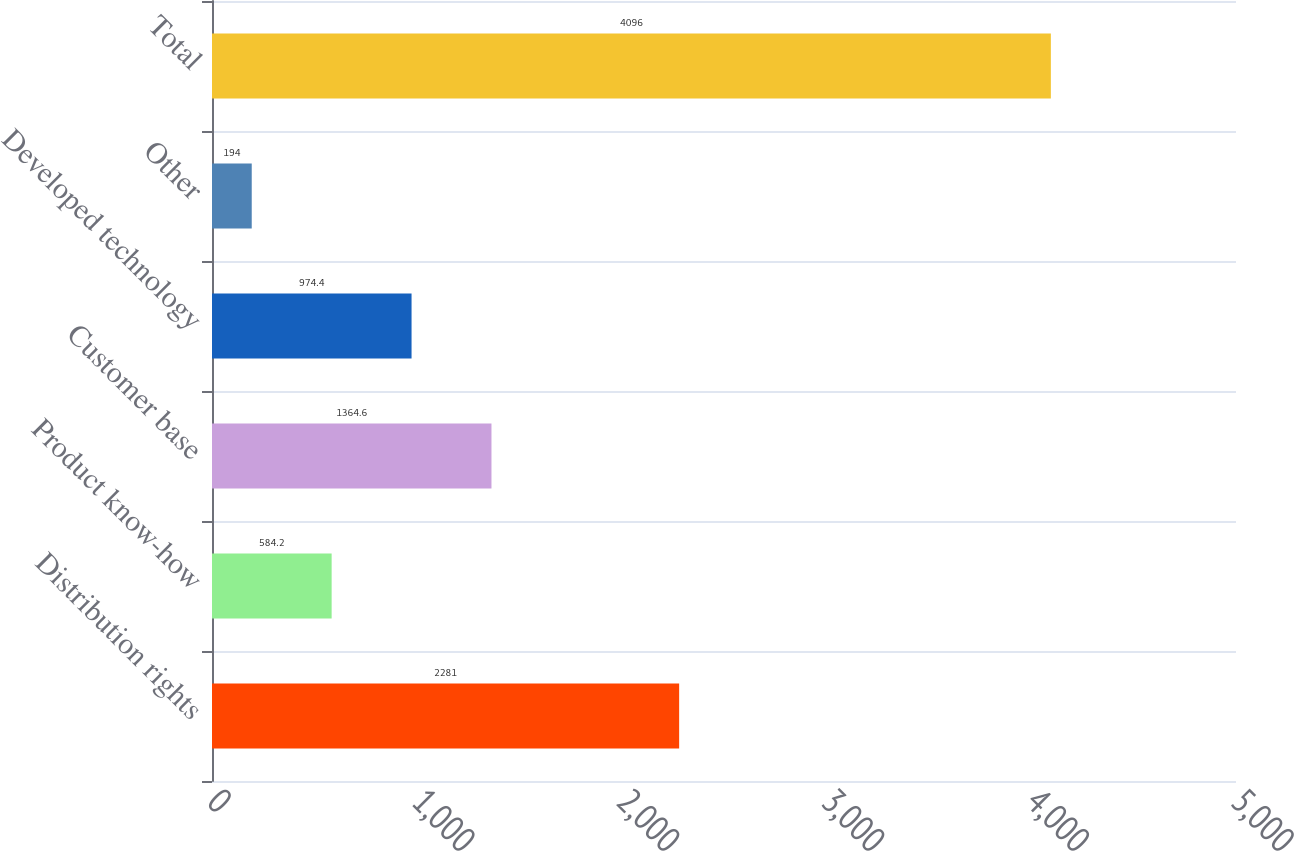<chart> <loc_0><loc_0><loc_500><loc_500><bar_chart><fcel>Distribution rights<fcel>Product know-how<fcel>Customer base<fcel>Developed technology<fcel>Other<fcel>Total<nl><fcel>2281<fcel>584.2<fcel>1364.6<fcel>974.4<fcel>194<fcel>4096<nl></chart> 